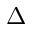Convert formula to latex. <formula><loc_0><loc_0><loc_500><loc_500>\Delta</formula> 